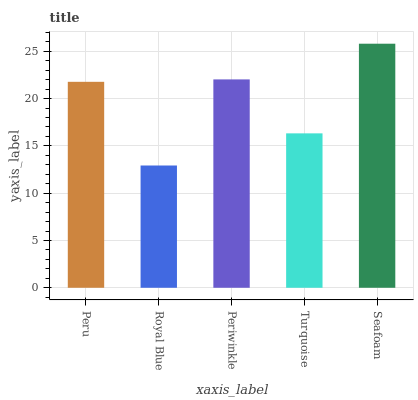Is Royal Blue the minimum?
Answer yes or no. Yes. Is Seafoam the maximum?
Answer yes or no. Yes. Is Periwinkle the minimum?
Answer yes or no. No. Is Periwinkle the maximum?
Answer yes or no. No. Is Periwinkle greater than Royal Blue?
Answer yes or no. Yes. Is Royal Blue less than Periwinkle?
Answer yes or no. Yes. Is Royal Blue greater than Periwinkle?
Answer yes or no. No. Is Periwinkle less than Royal Blue?
Answer yes or no. No. Is Peru the high median?
Answer yes or no. Yes. Is Peru the low median?
Answer yes or no. Yes. Is Periwinkle the high median?
Answer yes or no. No. Is Seafoam the low median?
Answer yes or no. No. 